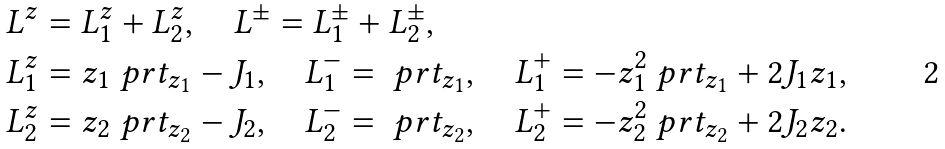<formula> <loc_0><loc_0><loc_500><loc_500>L ^ { z } & = L ^ { z } _ { 1 } + L ^ { z } _ { 2 } , \quad L ^ { \pm } = L ^ { \pm } _ { 1 } + L ^ { \pm } _ { 2 } , \\ L ^ { z } _ { 1 } & = z _ { 1 } \ p r t _ { z _ { 1 } } - J _ { 1 } , \quad L ^ { - } _ { 1 } = \ p r t _ { z _ { 1 } } , \quad L ^ { + } _ { 1 } = - z _ { 1 } ^ { 2 } \ p r t _ { z _ { 1 } } + 2 J _ { 1 } z _ { 1 } , \\ L ^ { z } _ { 2 } & = z _ { 2 } \ p r t _ { z _ { 2 } } - J _ { 2 } , \quad L ^ { - } _ { 2 } = \ p r t _ { z _ { 2 } } , \quad L ^ { + } _ { 2 } = - z _ { 2 } ^ { 2 } \ p r t _ { z _ { 2 } } + 2 J _ { 2 } z _ { 2 } .</formula> 